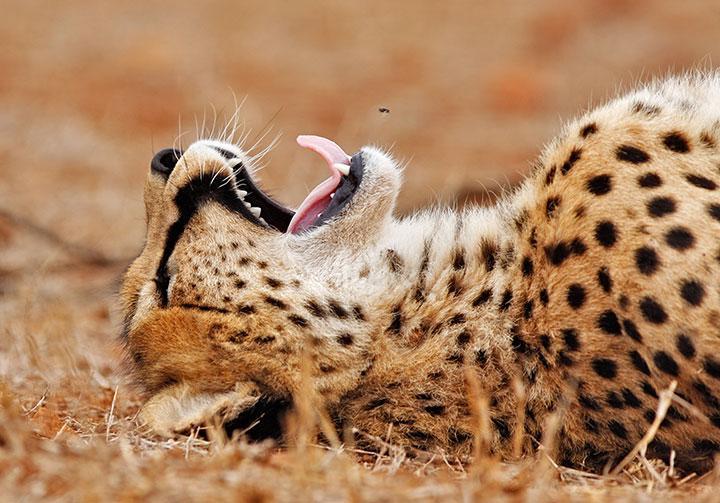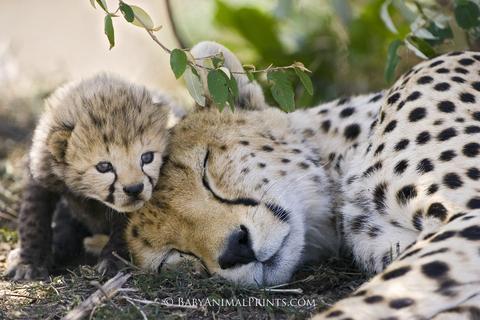The first image is the image on the left, the second image is the image on the right. For the images shown, is this caption "There is a cheetah sleeping in a tree" true? Answer yes or no. No. The first image is the image on the left, the second image is the image on the right. Evaluate the accuracy of this statement regarding the images: "There is one cheetah sleeping in a tree.". Is it true? Answer yes or no. No. 